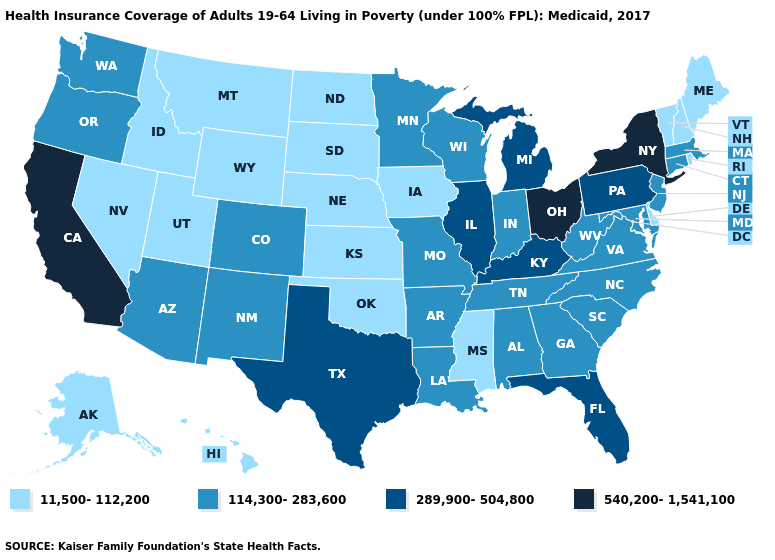How many symbols are there in the legend?
Be succinct. 4. Does Oregon have a higher value than Washington?
Write a very short answer. No. Does Mississippi have the same value as Iowa?
Write a very short answer. Yes. Which states hav the highest value in the South?
Give a very brief answer. Florida, Kentucky, Texas. Name the states that have a value in the range 289,900-504,800?
Short answer required. Florida, Illinois, Kentucky, Michigan, Pennsylvania, Texas. Which states hav the highest value in the Northeast?
Give a very brief answer. New York. What is the lowest value in states that border Washington?
Quick response, please. 11,500-112,200. What is the value of Colorado?
Concise answer only. 114,300-283,600. Among the states that border Wyoming , does Colorado have the lowest value?
Answer briefly. No. Among the states that border Wisconsin , which have the highest value?
Quick response, please. Illinois, Michigan. Name the states that have a value in the range 289,900-504,800?
Answer briefly. Florida, Illinois, Kentucky, Michigan, Pennsylvania, Texas. Does Michigan have a lower value than New York?
Be succinct. Yes. How many symbols are there in the legend?
Be succinct. 4. 